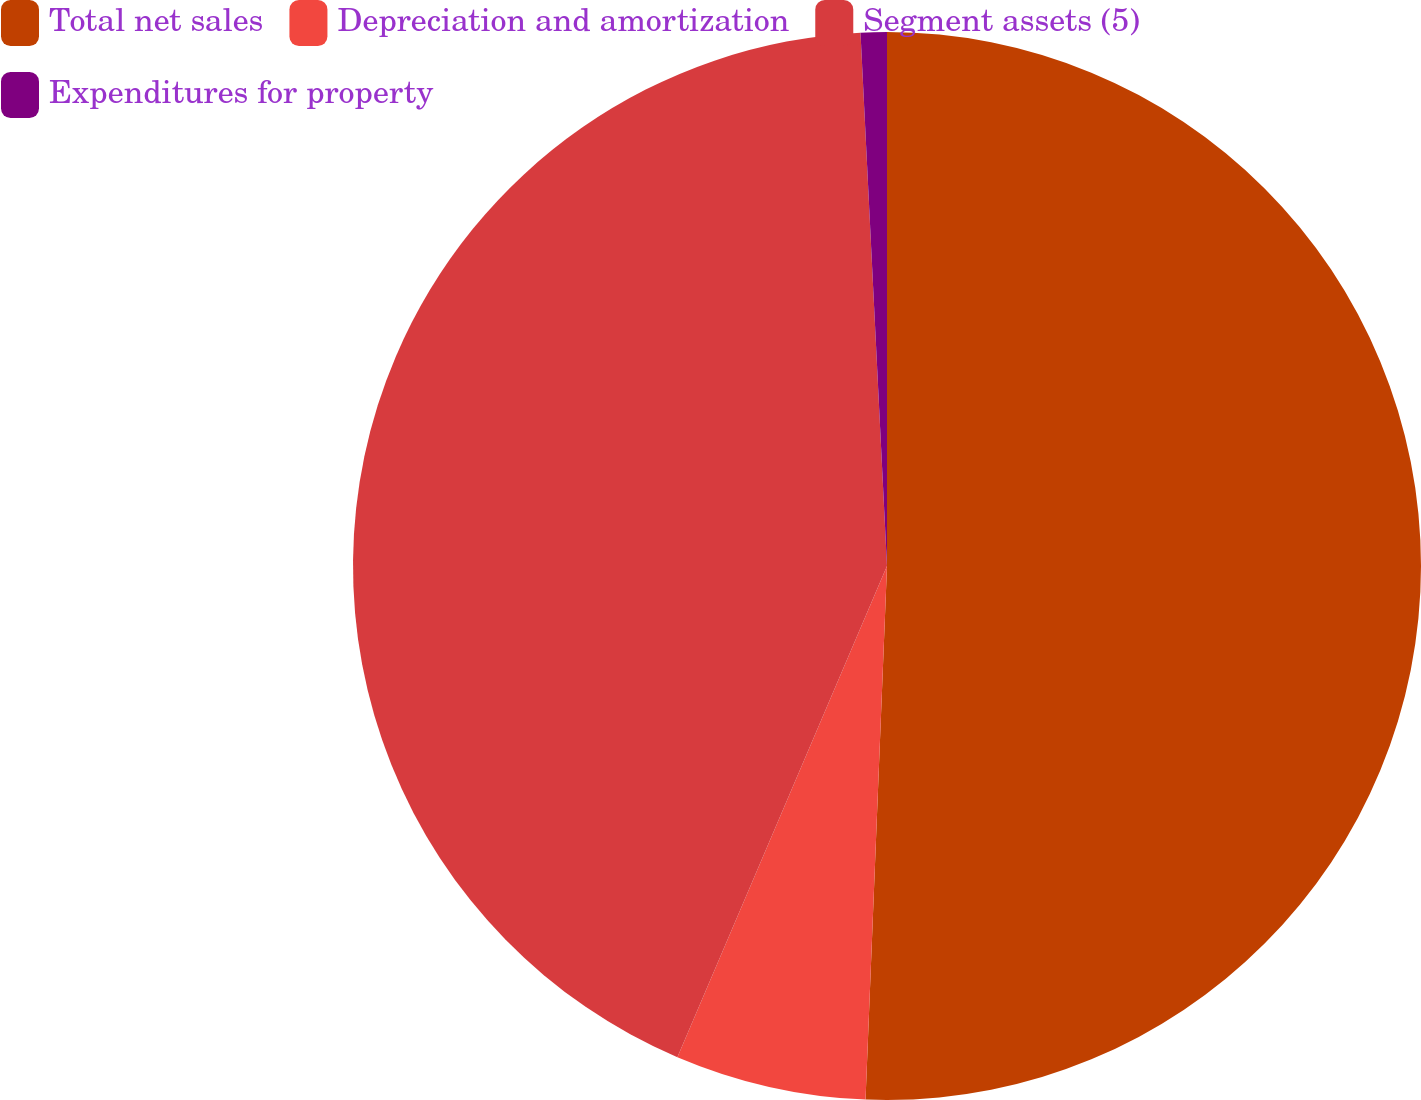Convert chart to OTSL. <chart><loc_0><loc_0><loc_500><loc_500><pie_chart><fcel>Total net sales<fcel>Depreciation and amortization<fcel>Segment assets (5)<fcel>Expenditures for property<nl><fcel>50.64%<fcel>5.78%<fcel>42.79%<fcel>0.79%<nl></chart> 